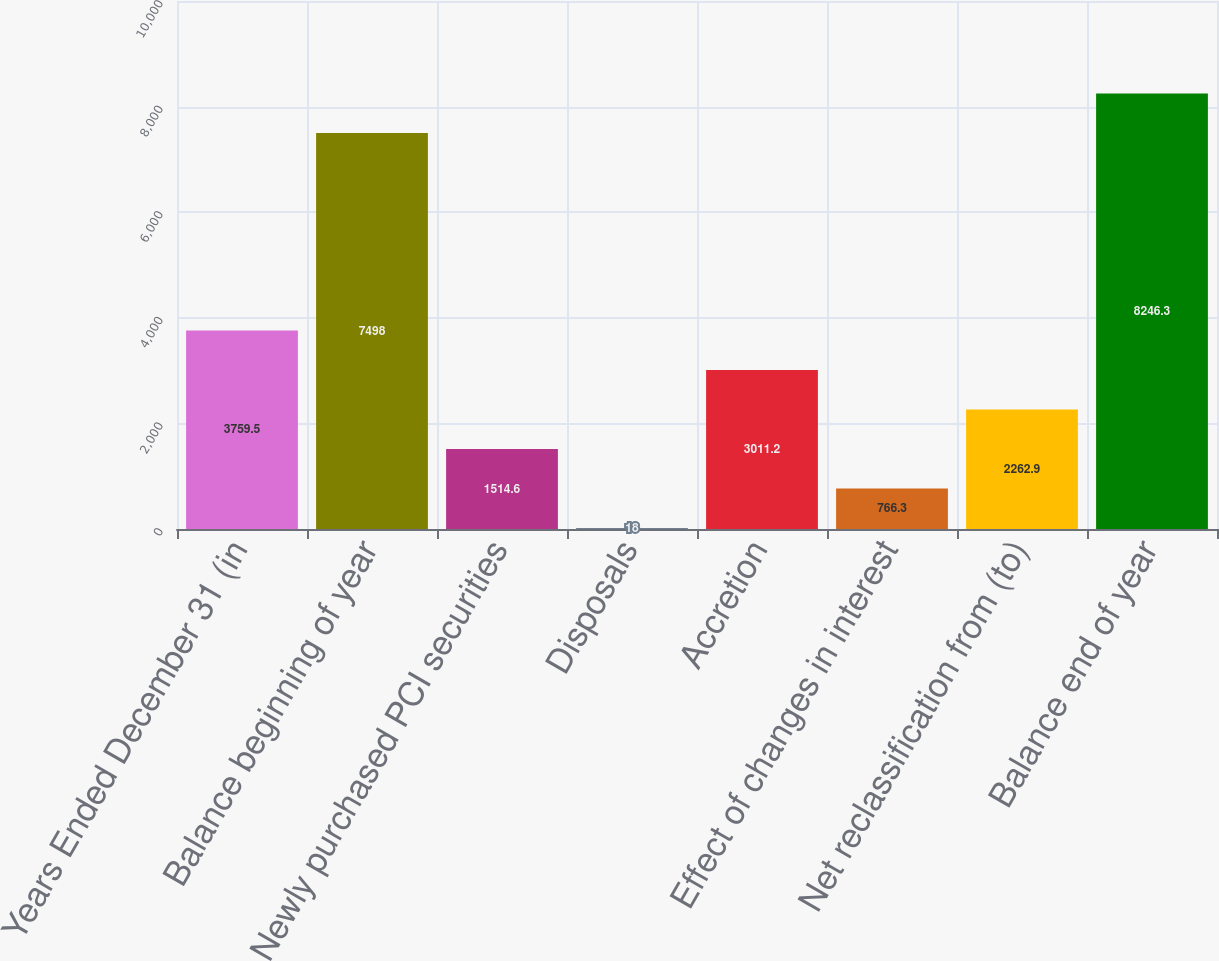Convert chart. <chart><loc_0><loc_0><loc_500><loc_500><bar_chart><fcel>Years Ended December 31 (in<fcel>Balance beginning of year<fcel>Newly purchased PCI securities<fcel>Disposals<fcel>Accretion<fcel>Effect of changes in interest<fcel>Net reclassification from (to)<fcel>Balance end of year<nl><fcel>3759.5<fcel>7498<fcel>1514.6<fcel>18<fcel>3011.2<fcel>766.3<fcel>2262.9<fcel>8246.3<nl></chart> 